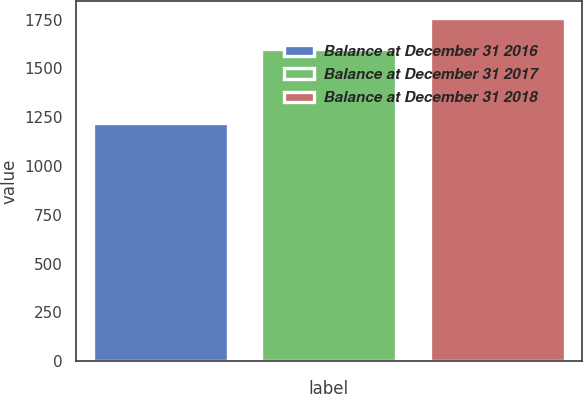Convert chart. <chart><loc_0><loc_0><loc_500><loc_500><bar_chart><fcel>Balance at December 31 2016<fcel>Balance at December 31 2017<fcel>Balance at December 31 2018<nl><fcel>1222.1<fcel>1600.3<fcel>1759.4<nl></chart> 